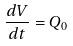Convert formula to latex. <formula><loc_0><loc_0><loc_500><loc_500>\frac { d V } { d t } = Q _ { 0 }</formula> 